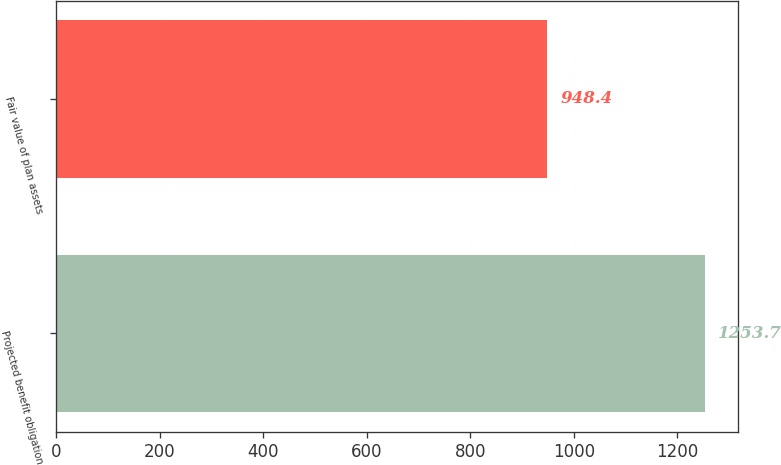Convert chart. <chart><loc_0><loc_0><loc_500><loc_500><bar_chart><fcel>Projected benefit obligation<fcel>Fair value of plan assets<nl><fcel>1253.7<fcel>948.4<nl></chart> 